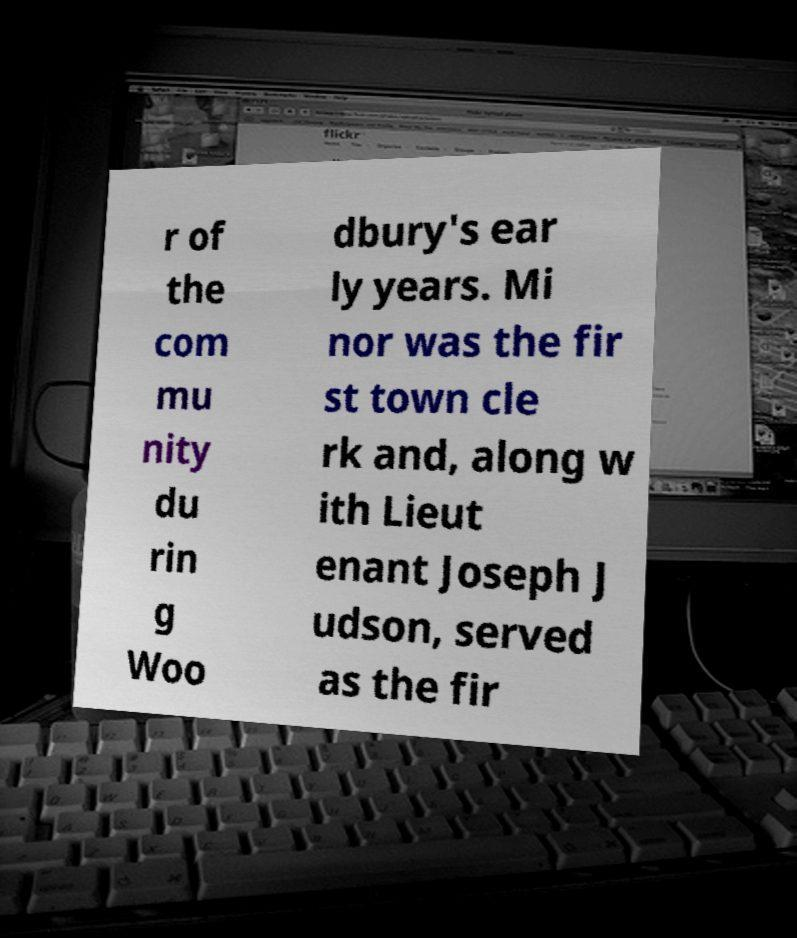Can you read and provide the text displayed in the image?This photo seems to have some interesting text. Can you extract and type it out for me? r of the com mu nity du rin g Woo dbury's ear ly years. Mi nor was the fir st town cle rk and, along w ith Lieut enant Joseph J udson, served as the fir 